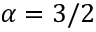Convert formula to latex. <formula><loc_0><loc_0><loc_500><loc_500>\alpha = 3 / 2</formula> 